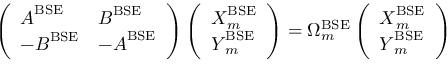<formula> <loc_0><loc_0><loc_500><loc_500>\left ( \begin{array} { l l } { A ^ { B S E } } & { B ^ { B S E } } \\ { - B ^ { B S E } } & { - A ^ { B S E } } \end{array} \right ) \left ( \begin{array} { l } { X _ { m } ^ { B S E } } \\ { Y _ { m } ^ { B S E } } \end{array} \right ) = \Omega _ { m } ^ { B S E } \left ( \begin{array} { l } { X _ { m } ^ { B S E } } \\ { Y _ { m } ^ { B S E } } \end{array} \right )</formula> 